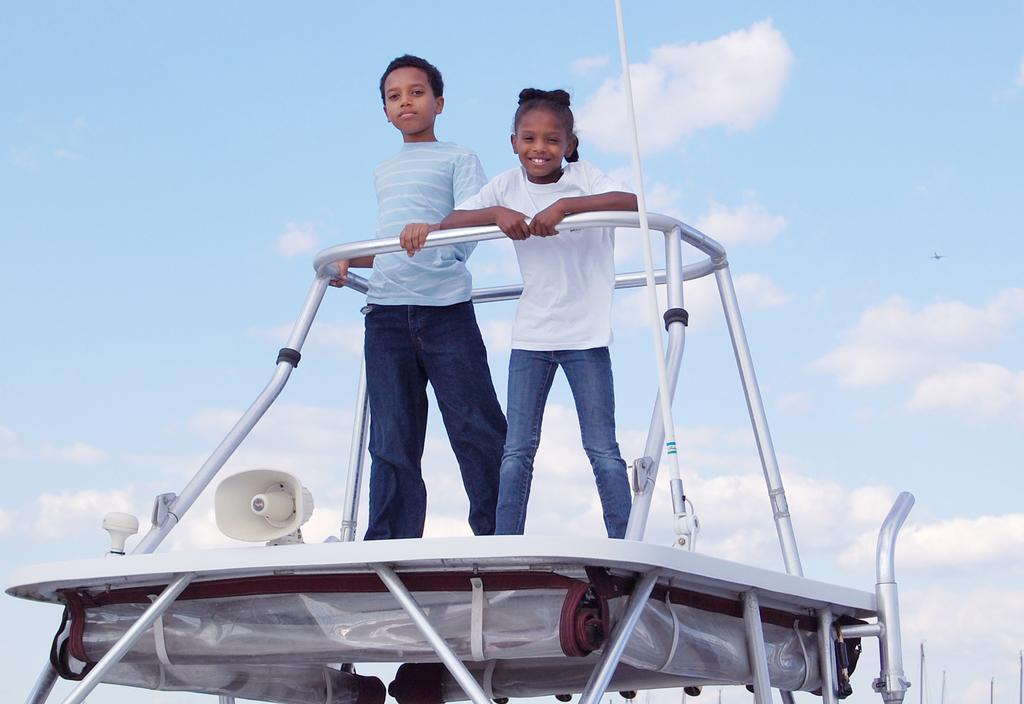What are the kids doing in the image? The kids are standing on a vehicle in the image. What can be seen in the background of the image? The sky is visible in the background of the image. What is the condition of the sky in the image? Clouds are present in the sky. How does the credit card help the kids on the vehicle in the image? There is no credit card present in the image, so it cannot help the kids on the vehicle. 